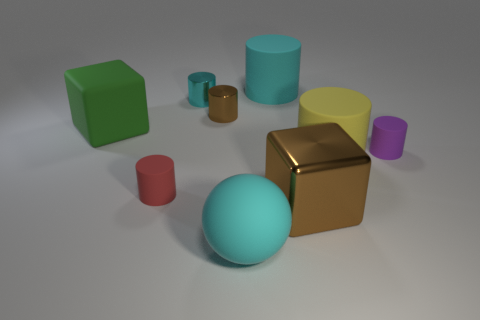Are there any objects in the image that have edges, and if so, how many? Yes, there are objects with edges in the image. There are a total of three: a green cube, a yellow cube, and a metallic-looking cube. Each cube has 12 edges as a characteristic of its geometric shape. What can you tell me about the lighting in the scene? The lighting in the scene appears to be soft and diffuse, with no hard shadows visible. It seems to come from multiple directions, as indicated by the subtle shadows cast by the objects. This kind of lighting typically creates a calm and even atmosphere. 